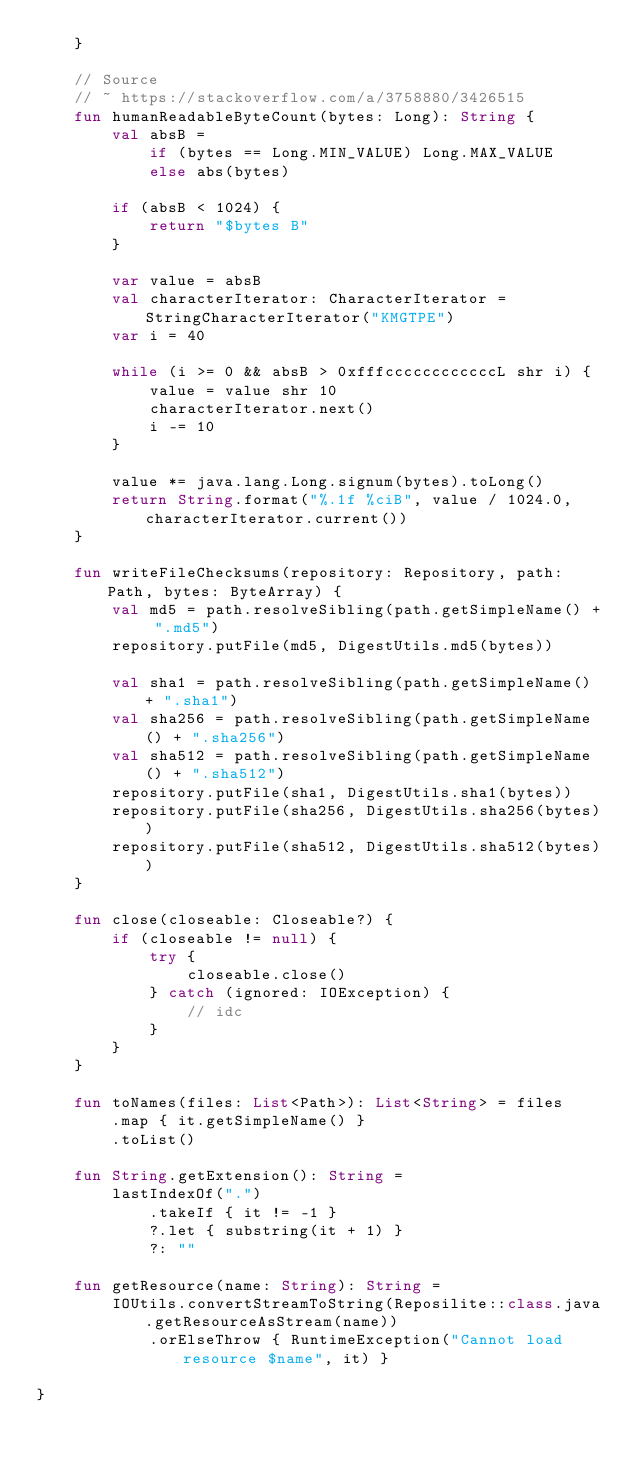<code> <loc_0><loc_0><loc_500><loc_500><_Kotlin_>    }

    // Source
    // ~ https://stackoverflow.com/a/3758880/3426515
    fun humanReadableByteCount(bytes: Long): String {
        val absB =
            if (bytes == Long.MIN_VALUE) Long.MAX_VALUE
            else abs(bytes)

        if (absB < 1024) {
            return "$bytes B"
        }

        var value = absB
        val characterIterator: CharacterIterator = StringCharacterIterator("KMGTPE")
        var i = 40

        while (i >= 0 && absB > 0xfffccccccccccccL shr i) {
            value = value shr 10
            characterIterator.next()
            i -= 10
        }

        value *= java.lang.Long.signum(bytes).toLong()
        return String.format("%.1f %ciB", value / 1024.0, characterIterator.current())
    }

    fun writeFileChecksums(repository: Repository, path: Path, bytes: ByteArray) {
        val md5 = path.resolveSibling(path.getSimpleName() + ".md5")
        repository.putFile(md5, DigestUtils.md5(bytes))

        val sha1 = path.resolveSibling(path.getSimpleName() + ".sha1")
        val sha256 = path.resolveSibling(path.getSimpleName() + ".sha256")
        val sha512 = path.resolveSibling(path.getSimpleName() + ".sha512")
        repository.putFile(sha1, DigestUtils.sha1(bytes))
        repository.putFile(sha256, DigestUtils.sha256(bytes))
        repository.putFile(sha512, DigestUtils.sha512(bytes))
    }

    fun close(closeable: Closeable?) {
        if (closeable != null) {
            try {
                closeable.close()
            } catch (ignored: IOException) {
                // idc
            }
        }
    }

    fun toNames(files: List<Path>): List<String> = files
        .map { it.getSimpleName() }
        .toList()

    fun String.getExtension(): String =
        lastIndexOf(".")
            .takeIf { it != -1 }
            ?.let { substring(it + 1) }
            ?: ""

    fun getResource(name: String): String =
        IOUtils.convertStreamToString(Reposilite::class.java.getResourceAsStream(name))
            .orElseThrow { RuntimeException("Cannot load resource $name", it) }

}</code> 